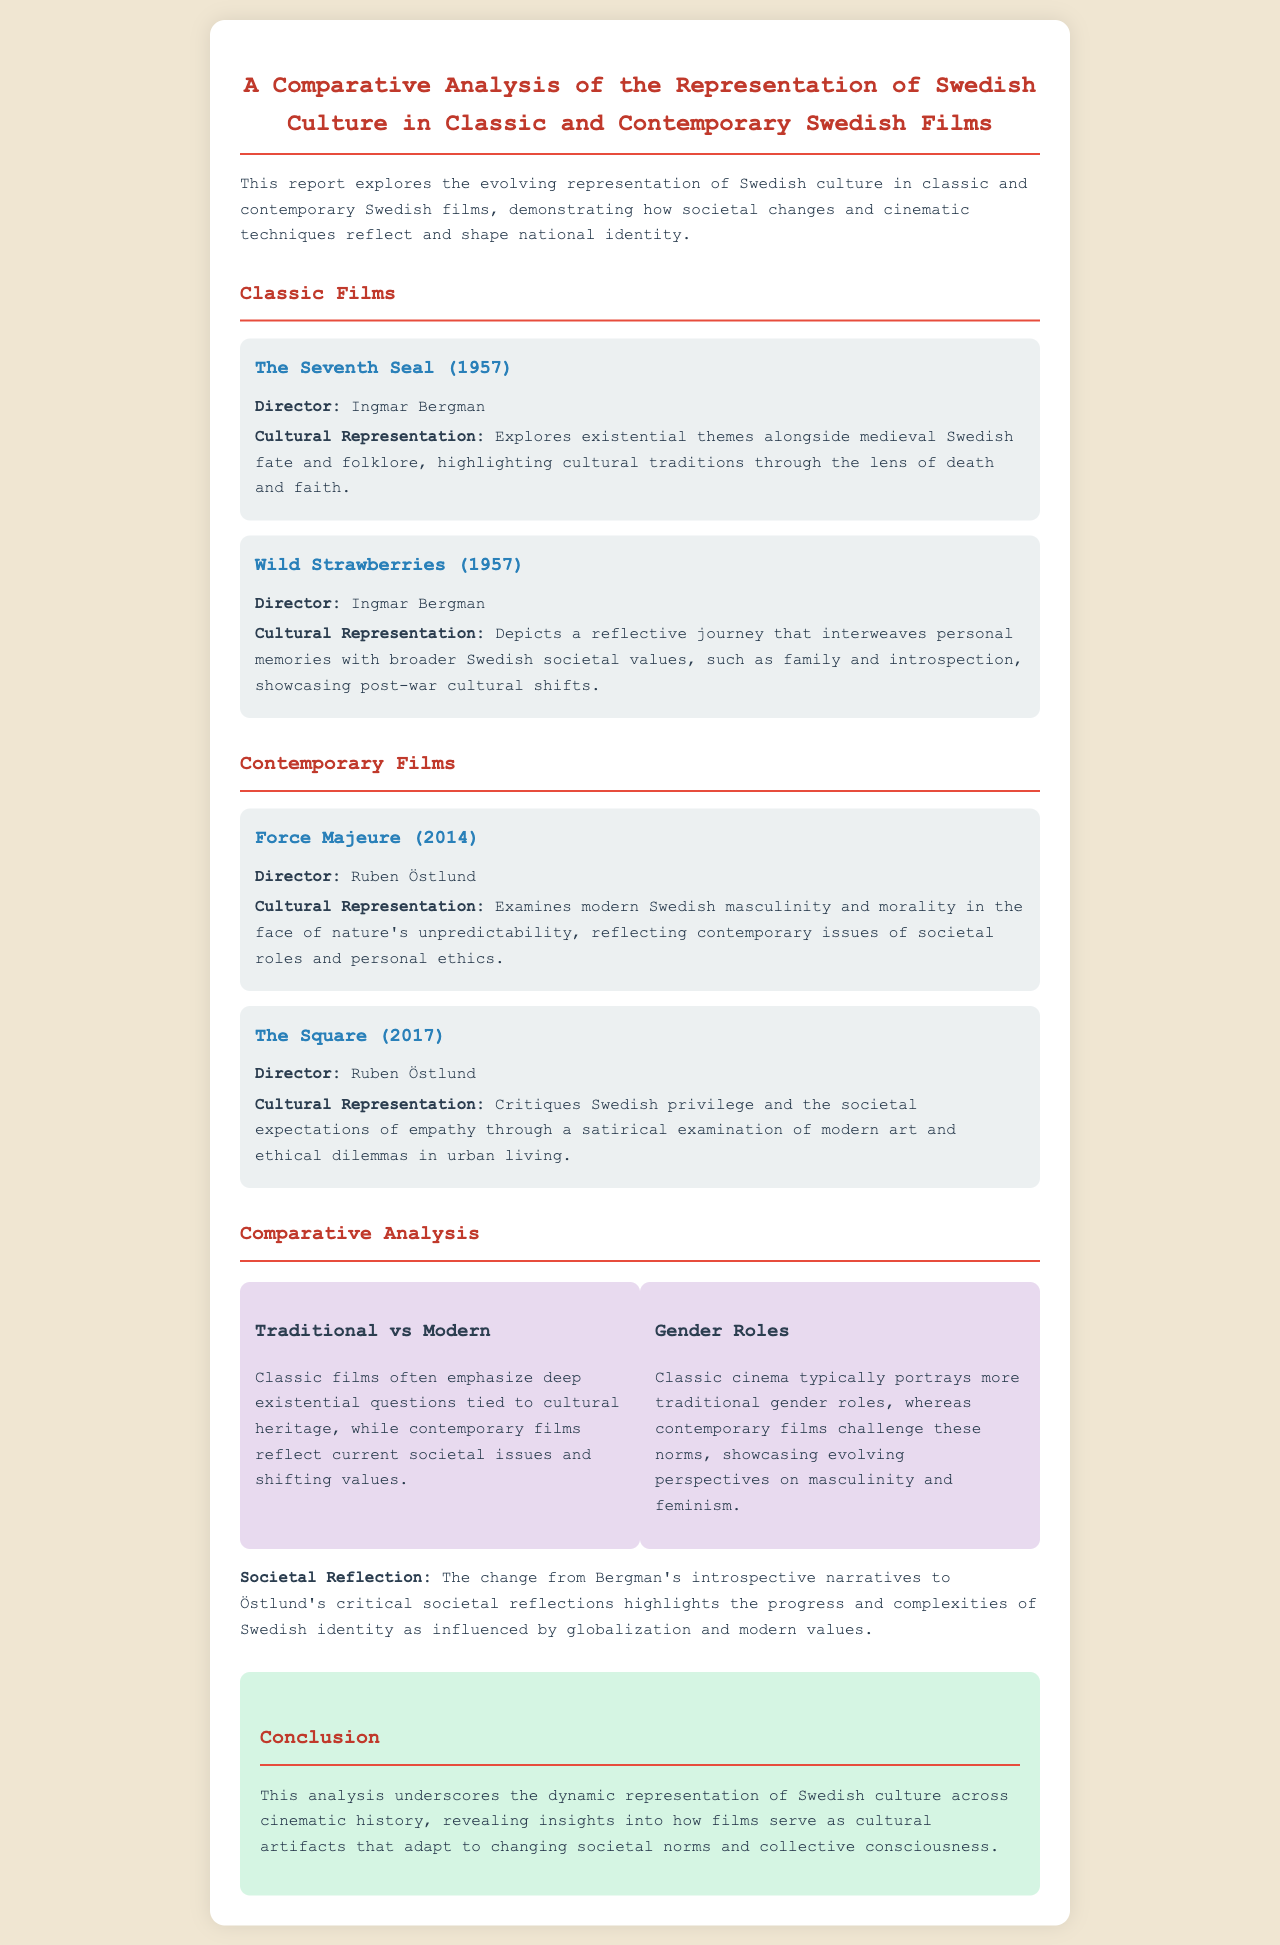What is the title of the report? The title of the report is found at the top of the document, summarizing the focus of the analysis.
Answer: A Comparative Analysis of the Representation of Swedish Culture in Classic and Contemporary Swedish Films Who directed "The Seventh Seal"? The director's name for "The Seventh Seal" is specified in the section discussing classic films.
Answer: Ingmar Bergman What year was "Force Majeure" released? The release year for "Force Majeure" is mentioned in the section presenting contemporary films.
Answer: 2014 What theme contrasts traditional and modern film representations? The themes section highlights various contrasts, emphasizing the difference between classic and contemporary approaches.
Answer: Traditional vs Modern Which director's films critique Swedish privilege? This inquiry leads to identifying the director responsible for exploring societal critiques in contemporary cinema.
Answer: Ruben Östlund What societal issue is examined in "The Square"? The specific issue represented in the film is highlighted within the cultural representation description.
Answer: Swedish privilege What is the main focus of the conclusion in the report? The conclusion wraps up the document by summarizing the overall insights drawn from the comparative analysis of films.
Answer: Dynamic representation of Swedish culture What aspect of culture do classic films often emphasize? The document mentions characteristics attributed to classic films, particularly regarding their thematic focus.
Answer: Existential questions What type of roles are typical in classic cinema according to the document? The document specifies common traits of portrayal regarding gender roles in classic films.
Answer: Traditional gender roles 